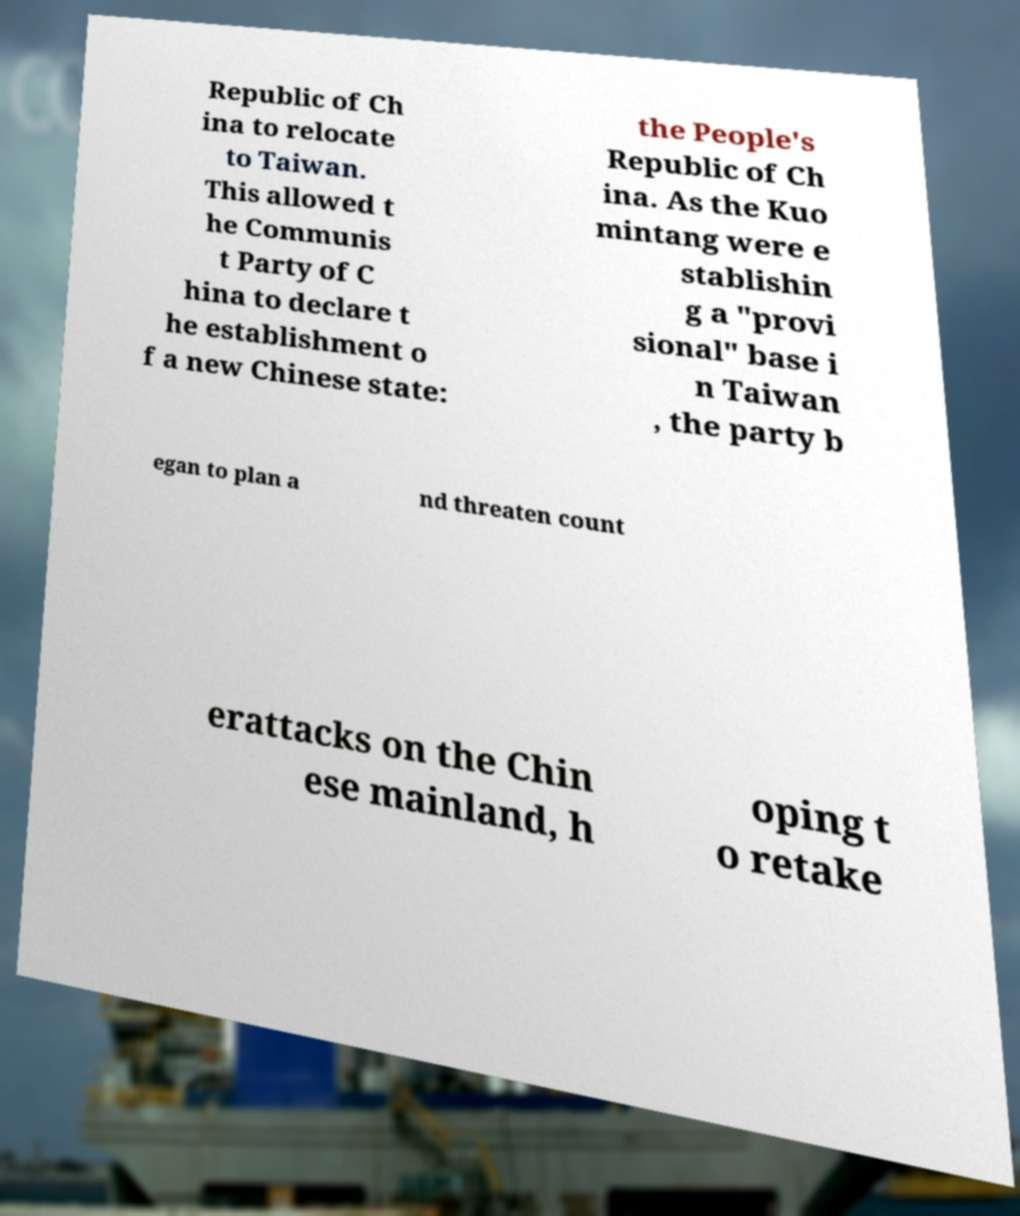Could you extract and type out the text from this image? Republic of Ch ina to relocate to Taiwan. This allowed t he Communis t Party of C hina to declare t he establishment o f a new Chinese state: the People's Republic of Ch ina. As the Kuo mintang were e stablishin g a "provi sional" base i n Taiwan , the party b egan to plan a nd threaten count erattacks on the Chin ese mainland, h oping t o retake 